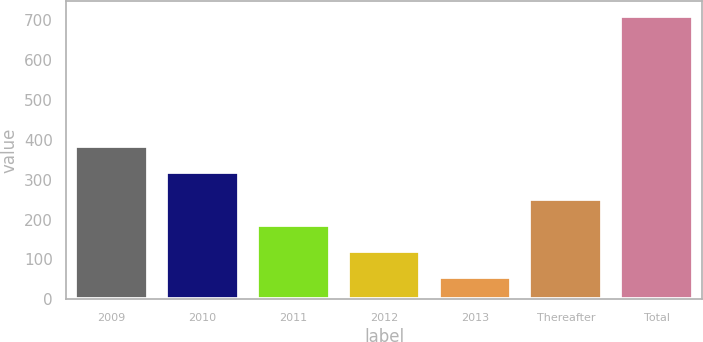Convert chart. <chart><loc_0><loc_0><loc_500><loc_500><bar_chart><fcel>2009<fcel>2010<fcel>2011<fcel>2012<fcel>2013<fcel>Thereafter<fcel>Total<nl><fcel>384<fcel>318.4<fcel>187.2<fcel>121.6<fcel>56<fcel>252.8<fcel>712<nl></chart> 